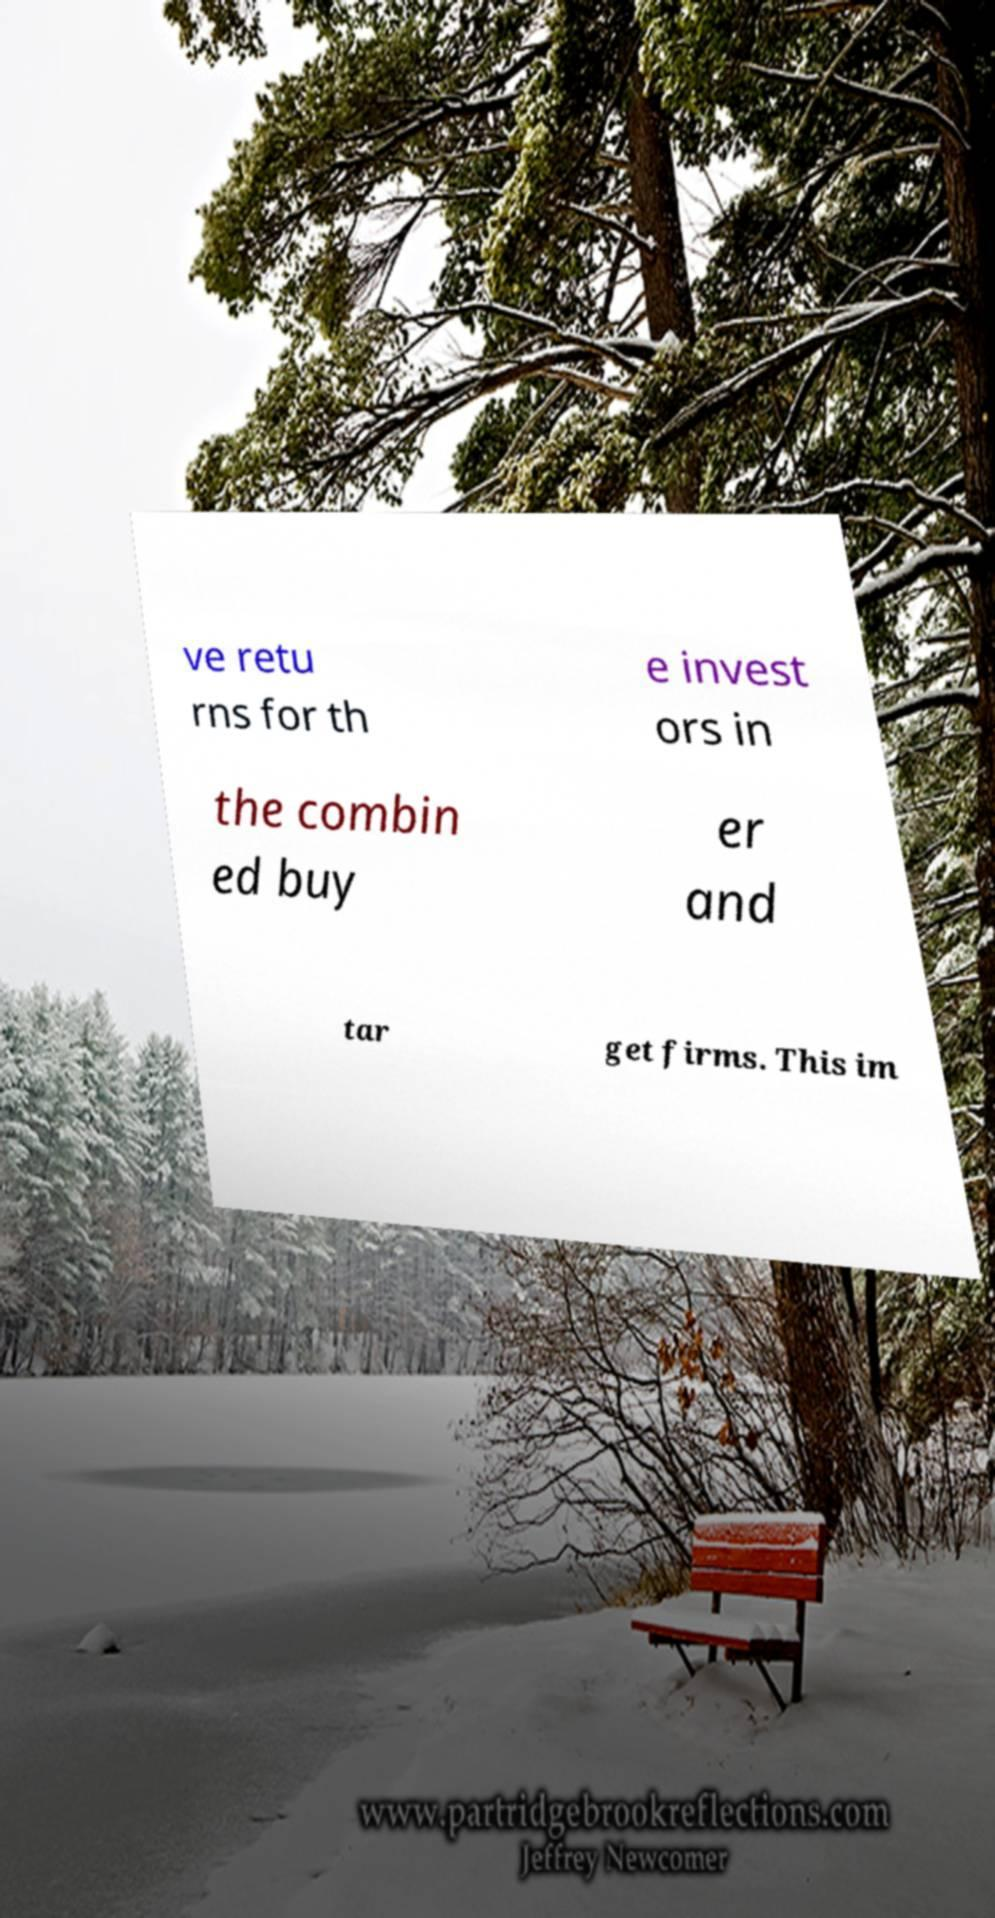Can you read and provide the text displayed in the image?This photo seems to have some interesting text. Can you extract and type it out for me? ve retu rns for th e invest ors in the combin ed buy er and tar get firms. This im 